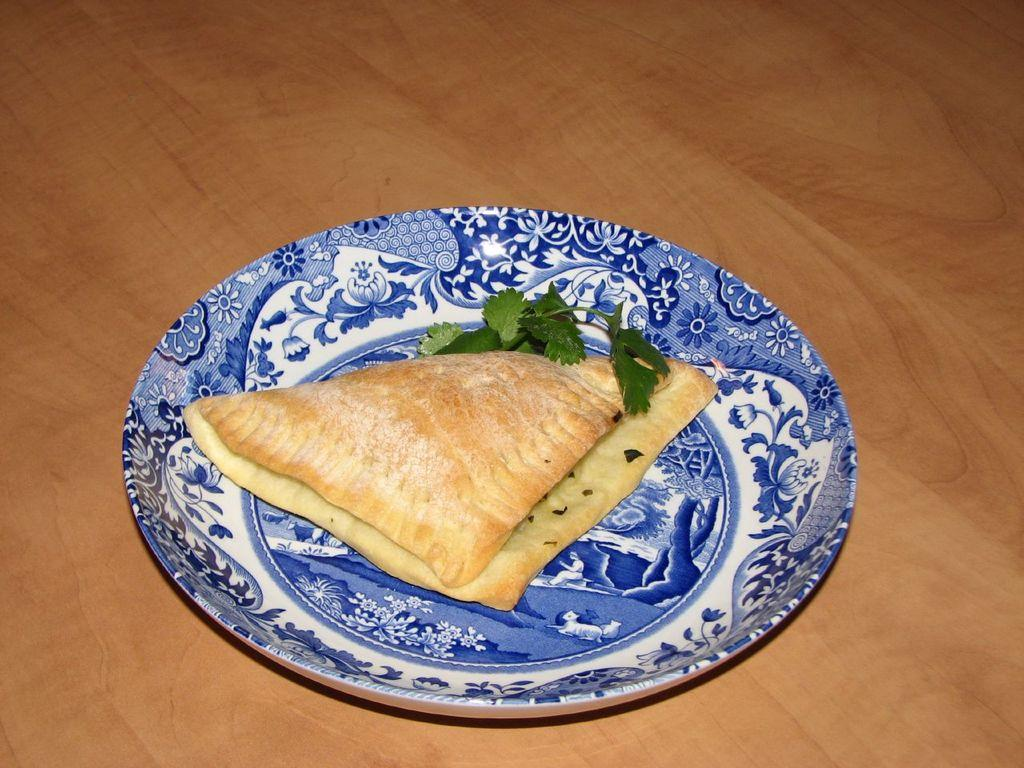What is on the plate that is visible in the image? There is bread and a leafy vegetable on the plate. What is the plate resting on in the image? The plate is on a wooden material. What type of tooth is visible in the image? There is no tooth present in the image. How does the image depict a good-bye scene? The image does not depict a good-bye scene; it shows a plate with bread and a leafy vegetable on a wooden material. 